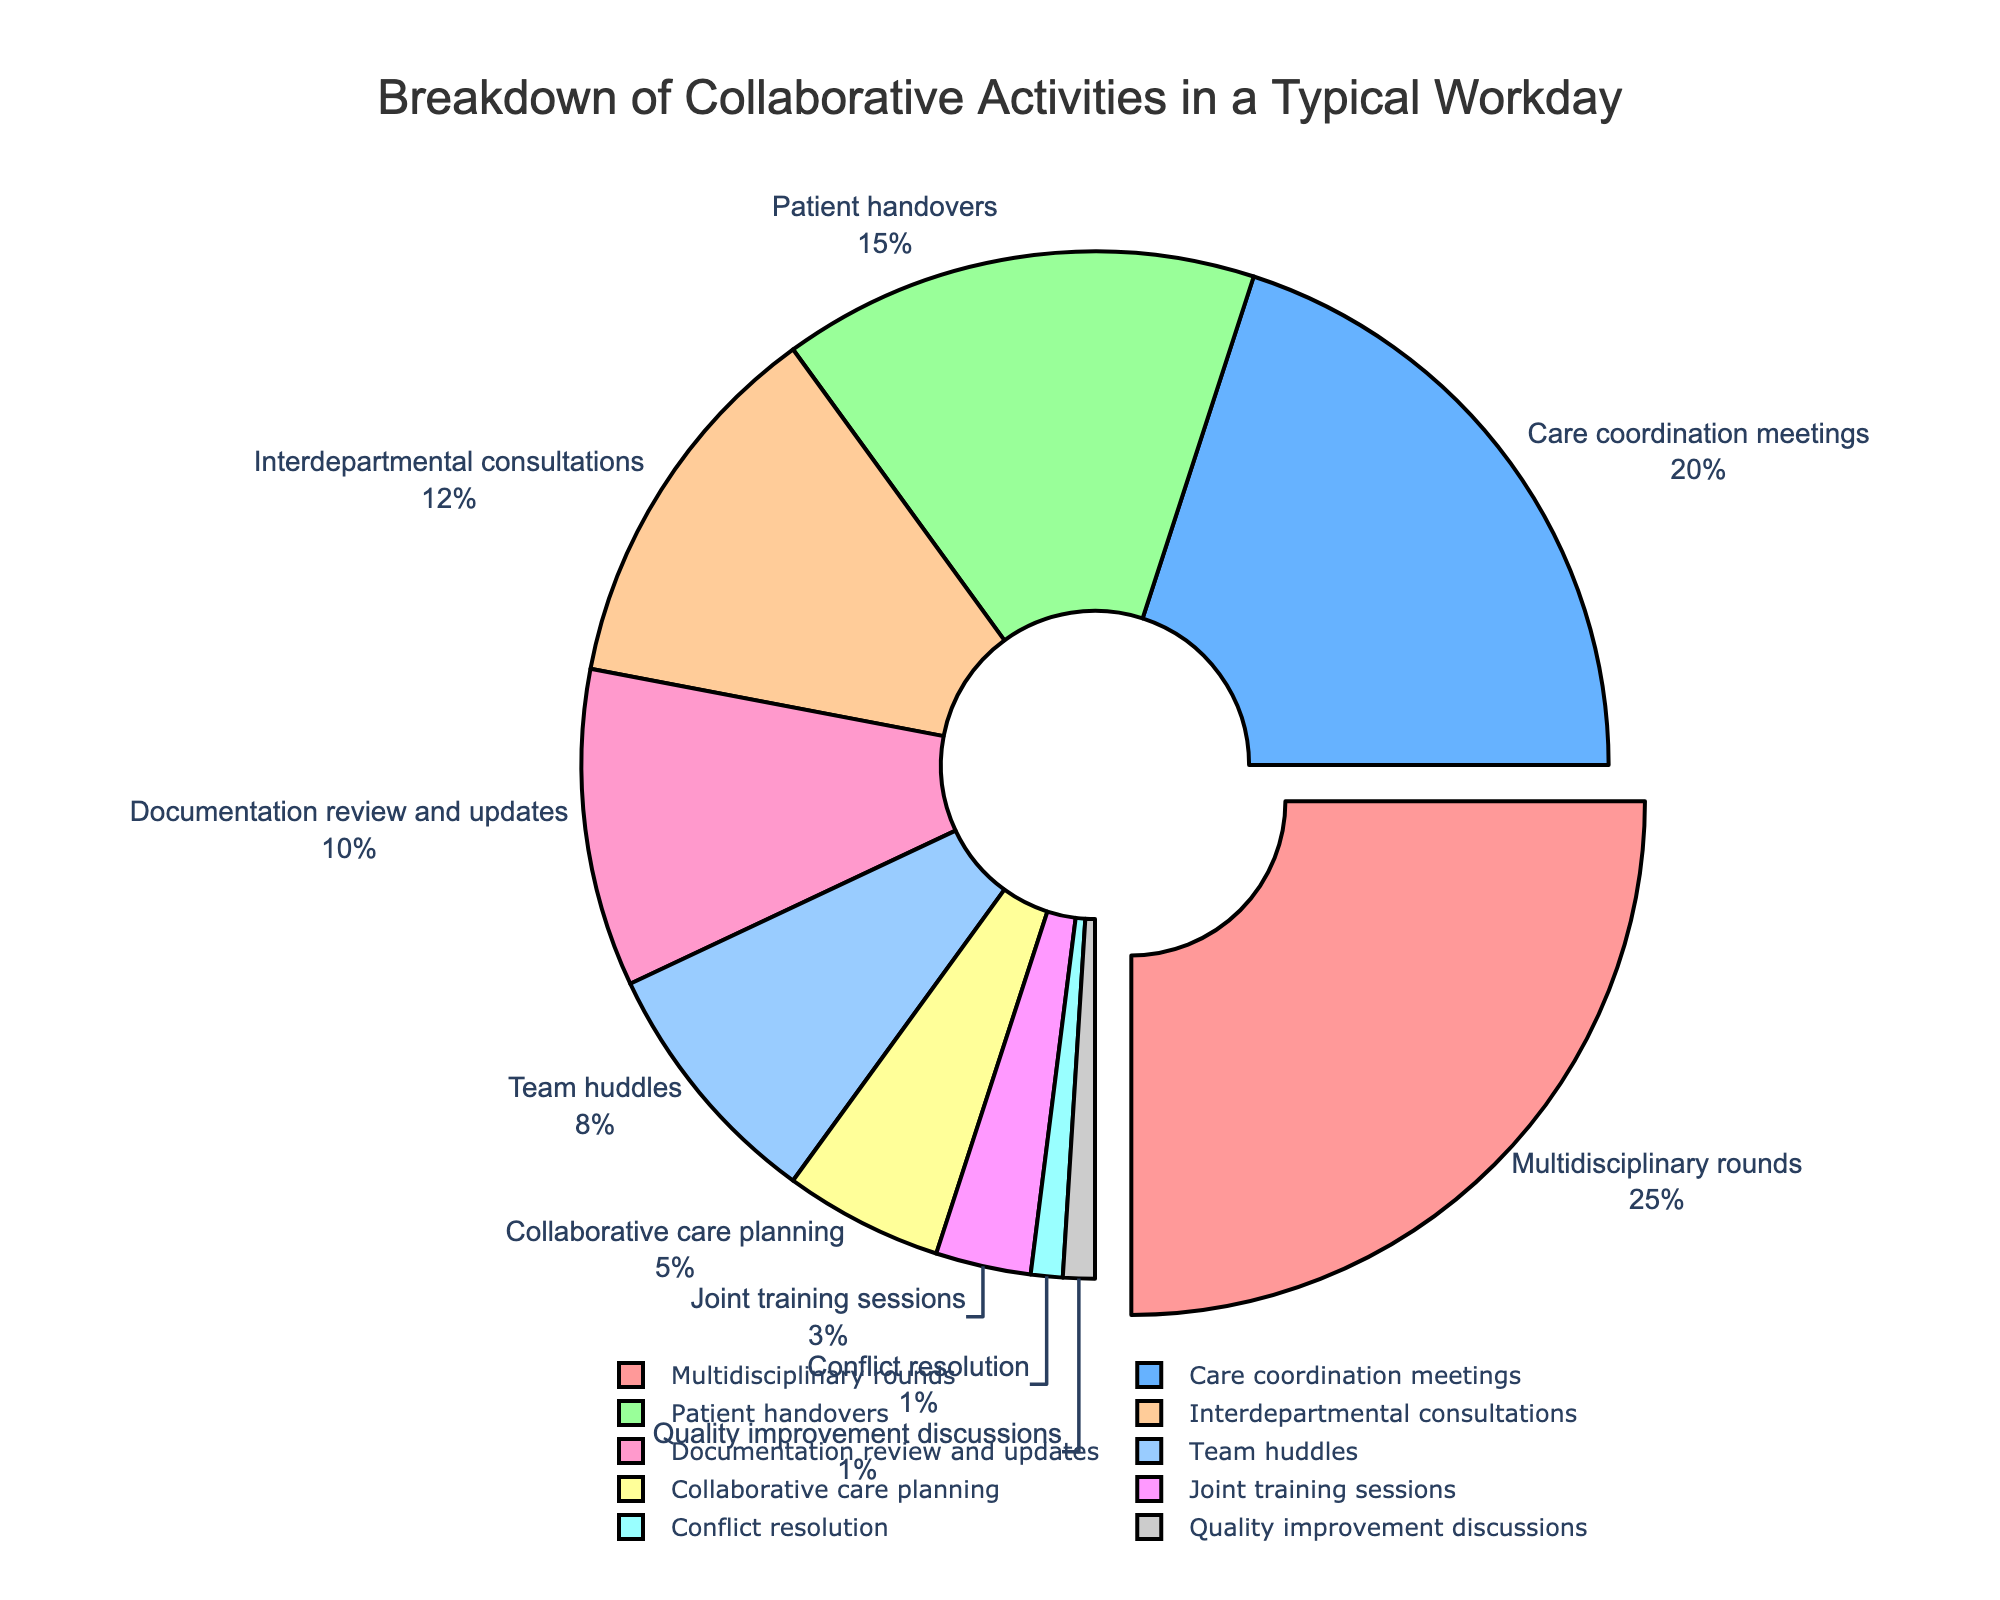What activity takes up the largest portion of a typical workday? The largest portion of the workday is indicated by the largest section of the pie chart, labeled "Multidisciplinary rounds" which is pulled out slightly from the rest.
Answer: Multidisciplinary rounds Which two activities combined take up the same amount of time as multidisciplinary rounds? The two activities that you need to look at will together add up to 25%. By adding Care coordination meetings (20%) and Conflict resolution (1%) with Team huddles (8%), you find that 20% + 5% = 25%.
Answer: Care coordination meetings and Patient handovers Are there more activities that take up 10% or more or those that take up less than 10% of the workday? First, identify the activities with 10% or more: Multidisciplinary rounds (25%), Care coordination meetings (20%), and Patient handovers (15%), which totals 3 activities. Then, count the activities with less than 10%, which are: Interdepartmental consultations (12%), Documentation review and updates (10%), Team huddles (8%), Collaborative care planning (5%), Joint training sessions (3%), Conflict resolution (1%), Quality improvement discussions (1%) totaling 7 activities.
Answer: Less than 10% How much more time is spent on care coordination meetings than on team huddles? Look at the percentages for Care coordination meetings (20%) and Team huddles (8%). Subtracting the two gives you 20% - 8%.
Answer: 12% What is the combined percentage of time spent on documentation review and updates, team huddles, and collaborative care planning? The percentages are as follows: Documentation review and updates (10%), Team huddles (8%), and Collaborative care planning (5%). Adding these together results in 10% + 8% + 5% = 23%.
Answer: 23% Which activity is represented by the smallest section of the pie chart? Look for the smallest section in the pie chart which is labeled "Conflict resolution" and "Quality improvement discussions," both at 1%.
Answer: Conflict resolution and Quality improvement discussions How does the time spent on patient handovers compare to the time spent on interdepartmental consultations? Look at the percentage for Patient handovers (15%) versus Interdepartmental consultations (12%). Patient handovers have a higher percentage.
Answer: Patient handovers take more time If we grouped all activities that take less than 5% together, what would be their total percentage? The activities with less than 5% are Joint training sessions (3%), Conflict resolution (1%), and Quality improvement discussions (1%). Adding these together results in 3% + 1% + 1% = 5%.
Answer: 5% What color represents the activity "Documentation review and updates"? Identify the color corresponding to the label "Documentation review and updates". It is colored in a specific pie slice.
Answer: Orange What percentage of time is allocated to activities that are specific to team coordination such as team huddles, collaborative care planning, and joint training sessions? Identify and sum the percentages for Team huddles (8%), Collaborative care planning (5%), and Joint training sessions (3%). The total is 8% + 5% + 3% = 16%.
Answer: 16% 